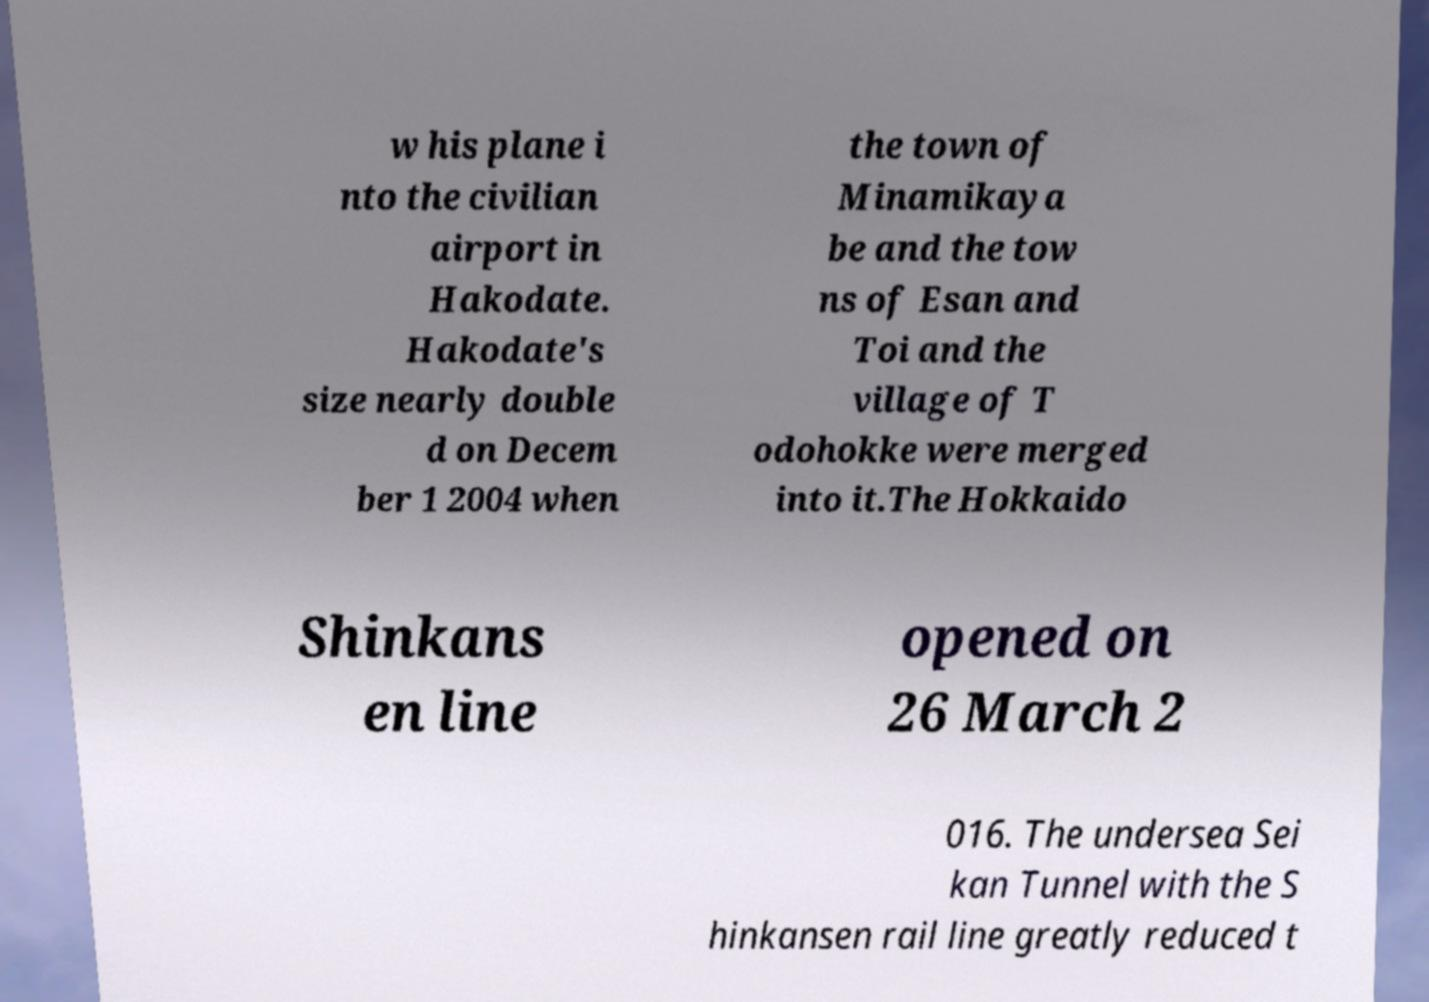Could you assist in decoding the text presented in this image and type it out clearly? w his plane i nto the civilian airport in Hakodate. Hakodate's size nearly double d on Decem ber 1 2004 when the town of Minamikaya be and the tow ns of Esan and Toi and the village of T odohokke were merged into it.The Hokkaido Shinkans en line opened on 26 March 2 016. The undersea Sei kan Tunnel with the S hinkansen rail line greatly reduced t 